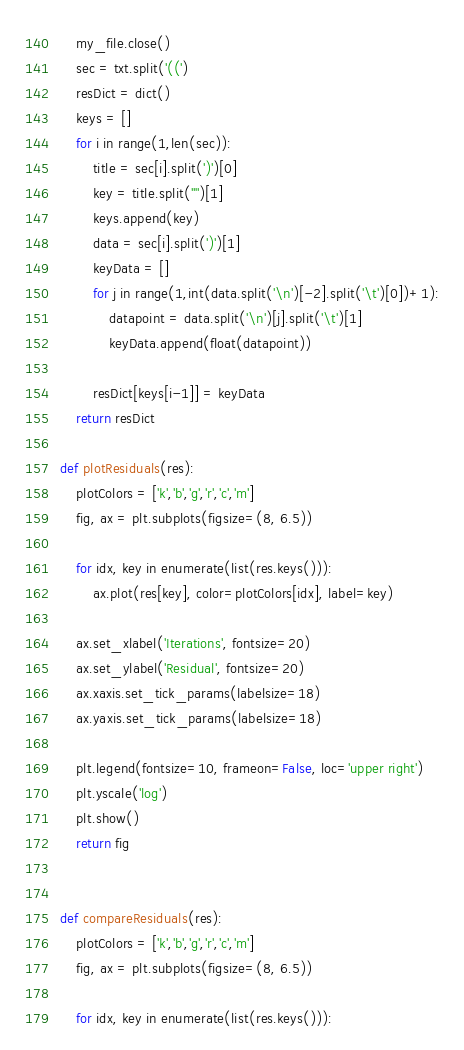Convert code to text. <code><loc_0><loc_0><loc_500><loc_500><_Python_>    my_file.close()
    sec = txt.split('((')
    resDict = dict()
    keys = []
    for i in range(1,len(sec)):
        title = sec[i].split(')')[0]
        key = title.split('"')[1]
        keys.append(key)
        data = sec[i].split(')')[1]
        keyData = []
        for j in range(1,int(data.split('\n')[-2].split('\t')[0])+1):
            datapoint = data.split('\n')[j].split('\t')[1]
            keyData.append(float(datapoint))

        resDict[keys[i-1]] = keyData
    return resDict

def plotResiduals(res):
    plotColors = ['k','b','g','r','c','m']
    fig, ax = plt.subplots(figsize=(8, 6.5))

    for idx, key in enumerate(list(res.keys())):
        ax.plot(res[key], color=plotColors[idx], label=key)

    ax.set_xlabel('Iterations', fontsize=20)
    ax.set_ylabel('Residual', fontsize=20)
    ax.xaxis.set_tick_params(labelsize=18)
    ax.yaxis.set_tick_params(labelsize=18)

    plt.legend(fontsize=10, frameon=False, loc='upper right')
    plt.yscale('log')
    plt.show()
    return fig


def compareResiduals(res):
    plotColors = ['k','b','g','r','c','m']
    fig, ax = plt.subplots(figsize=(8, 6.5))

    for idx, key in enumerate(list(res.keys())):</code> 